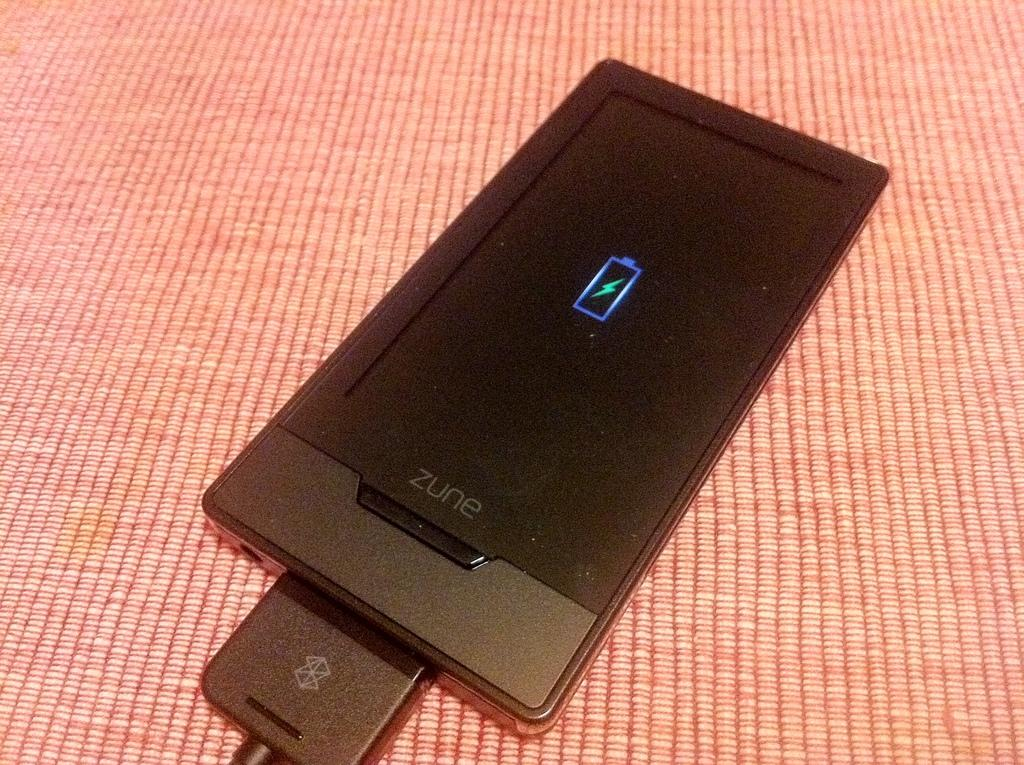<image>
Relay a brief, clear account of the picture shown. a phone that had the word zune at the bottom 